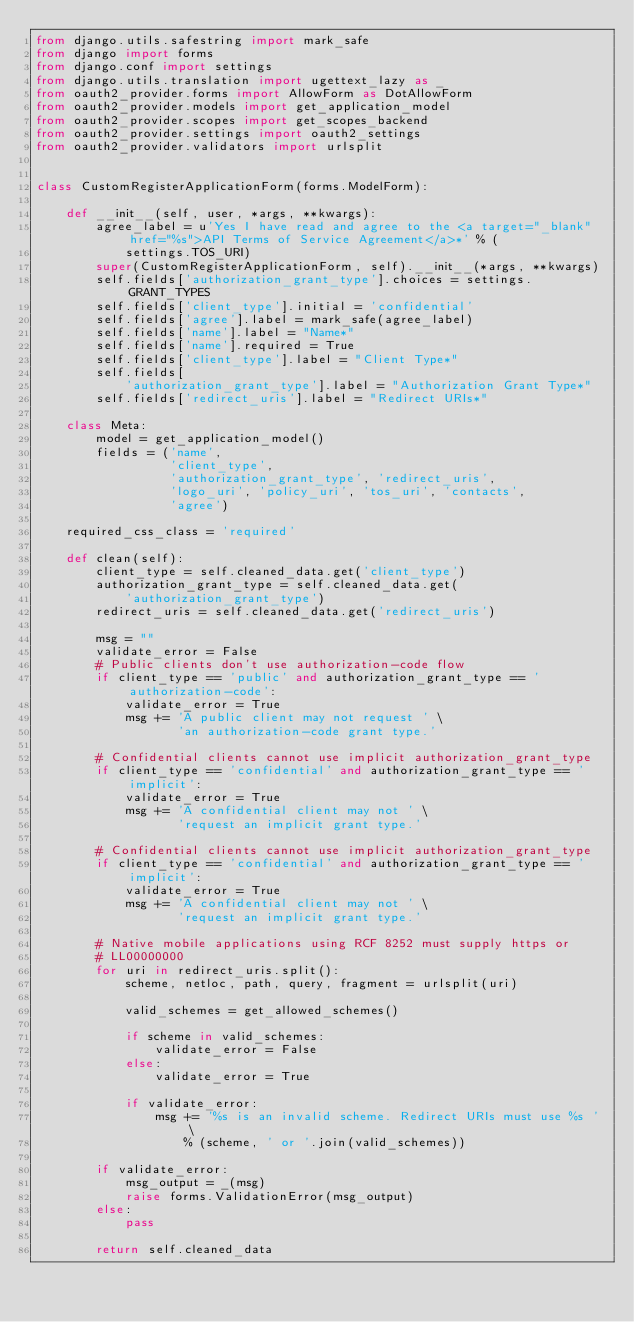<code> <loc_0><loc_0><loc_500><loc_500><_Python_>from django.utils.safestring import mark_safe
from django import forms
from django.conf import settings
from django.utils.translation import ugettext_lazy as _
from oauth2_provider.forms import AllowForm as DotAllowForm
from oauth2_provider.models import get_application_model
from oauth2_provider.scopes import get_scopes_backend
from oauth2_provider.settings import oauth2_settings
from oauth2_provider.validators import urlsplit


class CustomRegisterApplicationForm(forms.ModelForm):

    def __init__(self, user, *args, **kwargs):
        agree_label = u'Yes I have read and agree to the <a target="_blank" href="%s">API Terms of Service Agreement</a>*' % (
            settings.TOS_URI)
        super(CustomRegisterApplicationForm, self).__init__(*args, **kwargs)
        self.fields['authorization_grant_type'].choices = settings.GRANT_TYPES
        self.fields['client_type'].initial = 'confidential'
        self.fields['agree'].label = mark_safe(agree_label)
        self.fields['name'].label = "Name*"
        self.fields['name'].required = True
        self.fields['client_type'].label = "Client Type*"
        self.fields[
            'authorization_grant_type'].label = "Authorization Grant Type*"
        self.fields['redirect_uris'].label = "Redirect URIs*"

    class Meta:
        model = get_application_model()
        fields = ('name',
                  'client_type',
                  'authorization_grant_type', 'redirect_uris',
                  'logo_uri', 'policy_uri', 'tos_uri', 'contacts',
                  'agree')

    required_css_class = 'required'

    def clean(self):
        client_type = self.cleaned_data.get('client_type')
        authorization_grant_type = self.cleaned_data.get(
            'authorization_grant_type')
        redirect_uris = self.cleaned_data.get('redirect_uris')

        msg = ""
        validate_error = False
        # Public clients don't use authorization-code flow
        if client_type == 'public' and authorization_grant_type == 'authorization-code':
            validate_error = True
            msg += 'A public client may not request ' \
                   'an authorization-code grant type.'

        # Confidential clients cannot use implicit authorization_grant_type
        if client_type == 'confidential' and authorization_grant_type == 'implicit':
            validate_error = True
            msg += 'A confidential client may not ' \
                   'request an implicit grant type.'

        # Confidential clients cannot use implicit authorization_grant_type
        if client_type == 'confidential' and authorization_grant_type == 'implicit':
            validate_error = True
            msg += 'A confidential client may not ' \
                   'request an implicit grant type.'

        # Native mobile applications using RCF 8252 must supply https or
        # LL00000000
        for uri in redirect_uris.split():
            scheme, netloc, path, query, fragment = urlsplit(uri)

            valid_schemes = get_allowed_schemes()

            if scheme in valid_schemes:
                validate_error = False
            else:
                validate_error = True

            if validate_error:
                msg += '%s is an invalid scheme. Redirect URIs must use %s ' \
                    % (scheme, ' or '.join(valid_schemes))

        if validate_error:
            msg_output = _(msg)
            raise forms.ValidationError(msg_output)
        else:
            pass

        return self.cleaned_data
</code> 